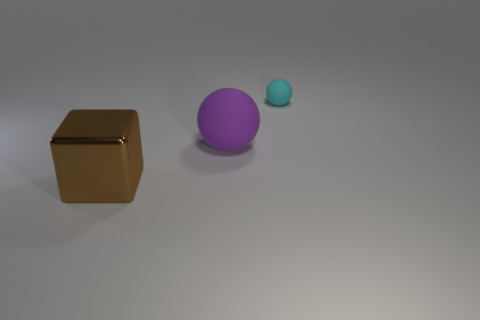There is a object in front of the ball to the left of the cyan matte object; what shape is it?
Your response must be concise. Cube. Is the color of the large shiny cube the same as the large matte thing?
Keep it short and to the point. No. What number of brown objects are big blocks or small matte cylinders?
Give a very brief answer. 1. Are there any large spheres left of the large purple ball?
Make the answer very short. No. The cyan matte ball is what size?
Offer a terse response. Small. There is a purple rubber thing that is the same shape as the cyan matte object; what size is it?
Offer a very short reply. Large. How many big objects are in front of the big thing that is right of the big cube?
Provide a short and direct response. 1. Is the sphere that is left of the small cyan rubber object made of the same material as the brown cube that is on the left side of the cyan matte sphere?
Ensure brevity in your answer.  No. What number of other cyan things are the same shape as the small cyan object?
Your response must be concise. 0. Is the shape of the large object behind the block the same as the object to the right of the large purple rubber sphere?
Give a very brief answer. Yes. 